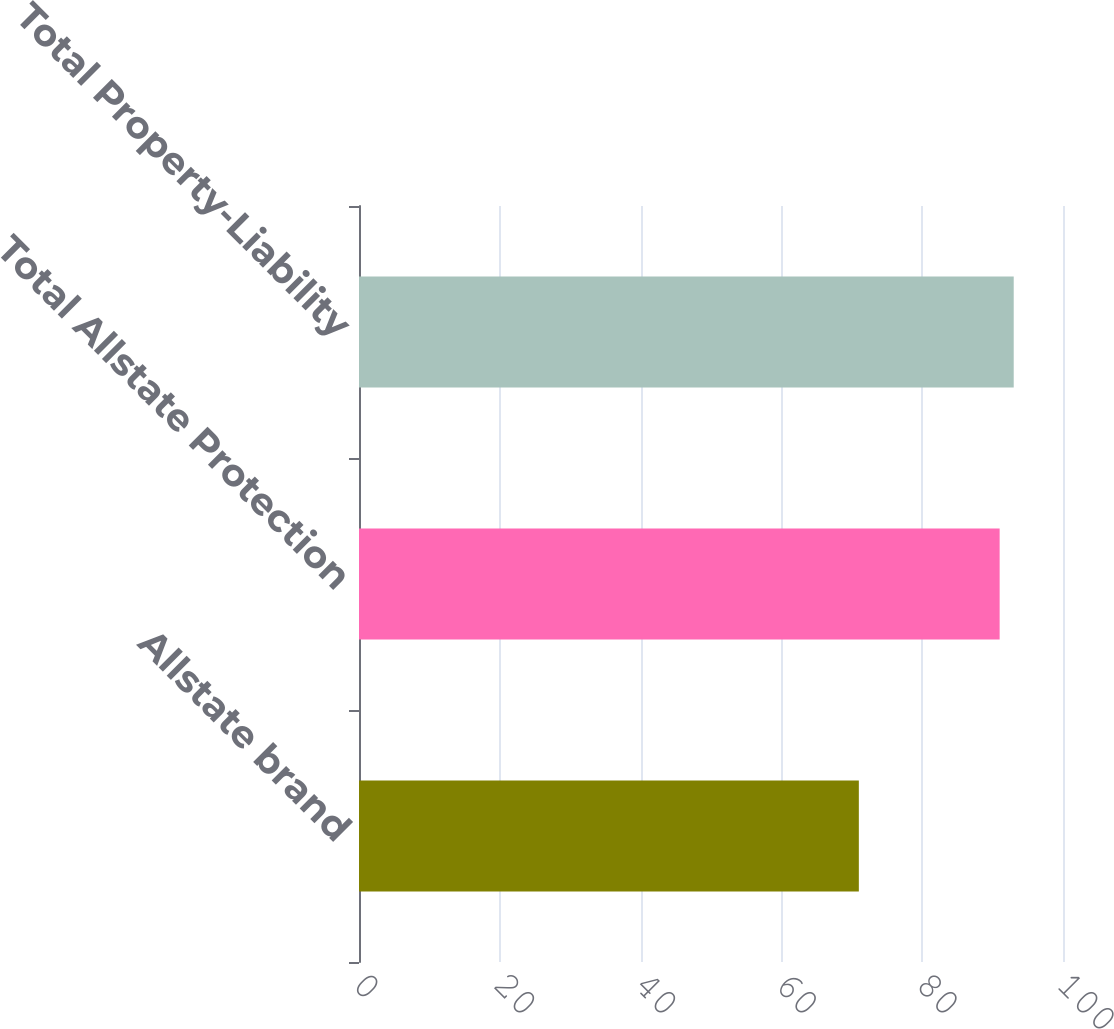Convert chart. <chart><loc_0><loc_0><loc_500><loc_500><bar_chart><fcel>Allstate brand<fcel>Total Allstate Protection<fcel>Total Property-Liability<nl><fcel>71<fcel>91<fcel>93<nl></chart> 